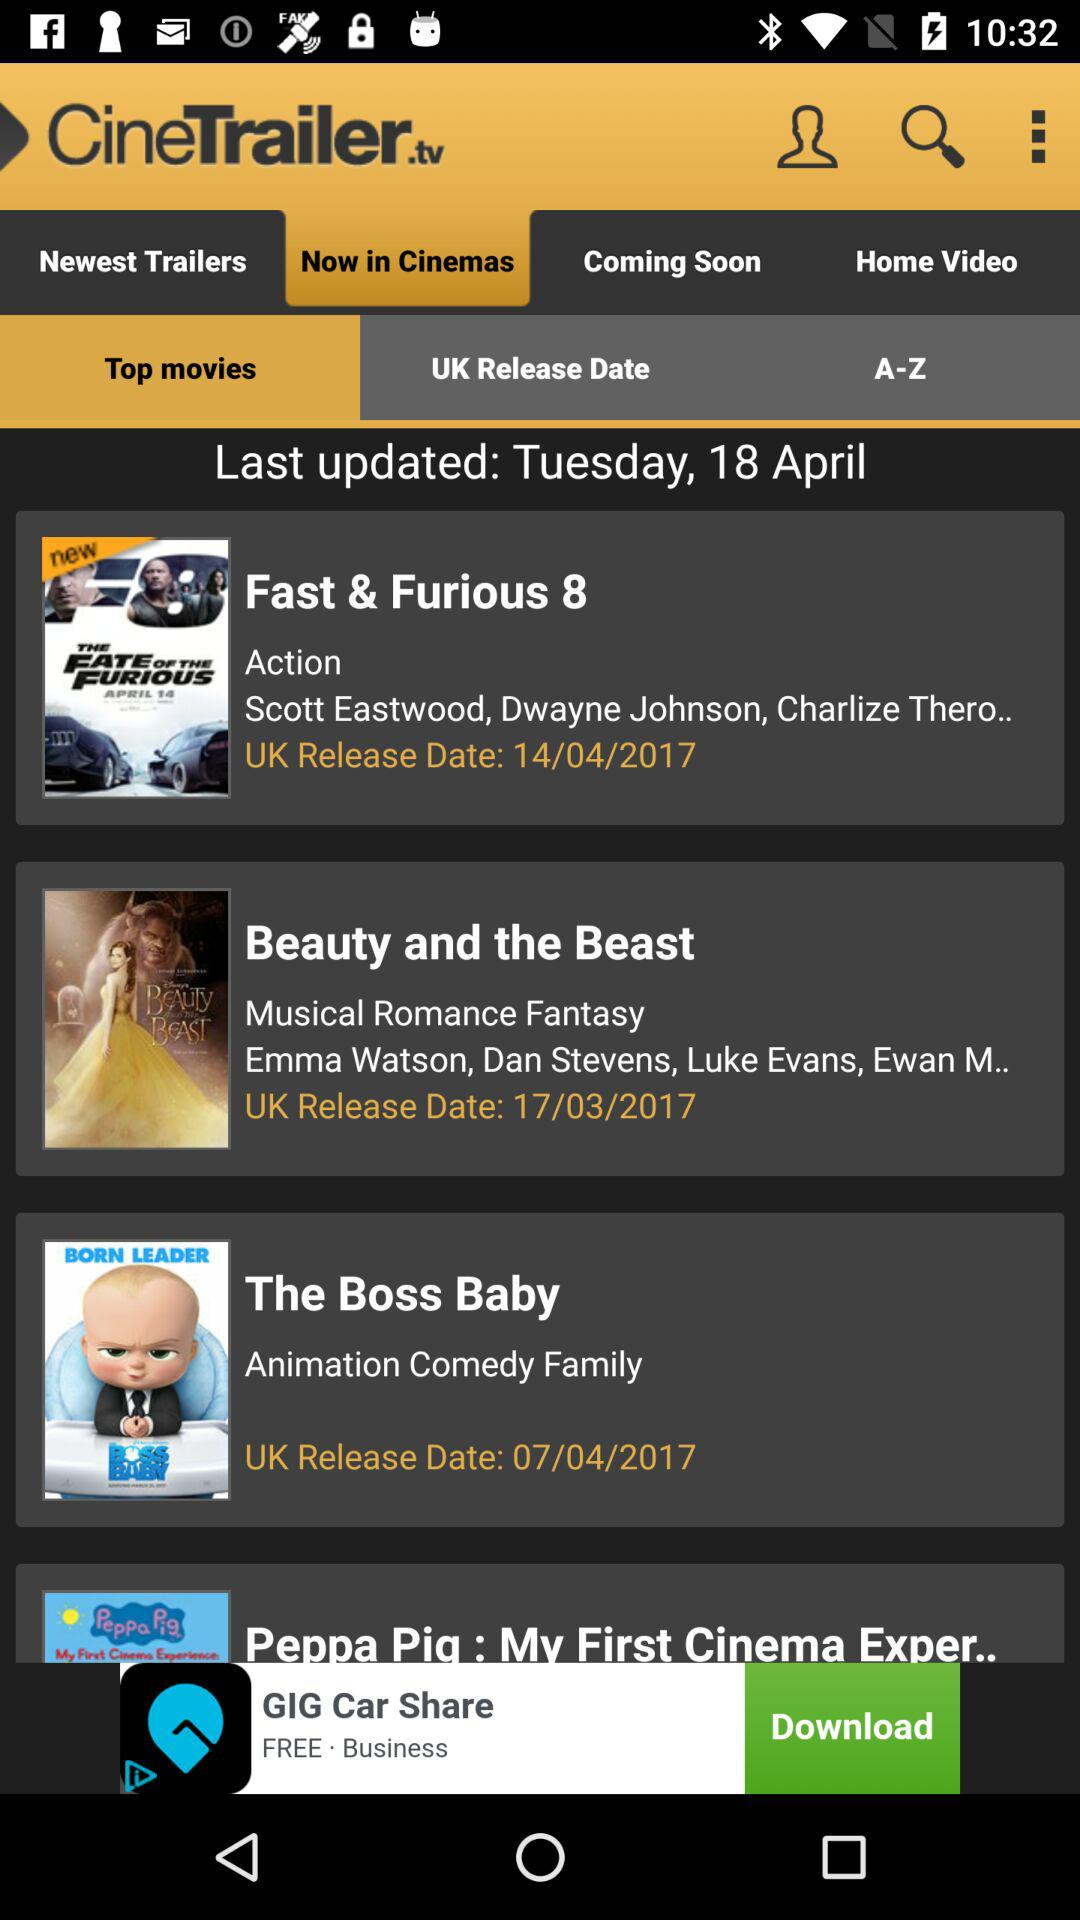What is the genre of "The Boss Baby" movie? "The Boss Baby" is an animated comedy and a family movie. 